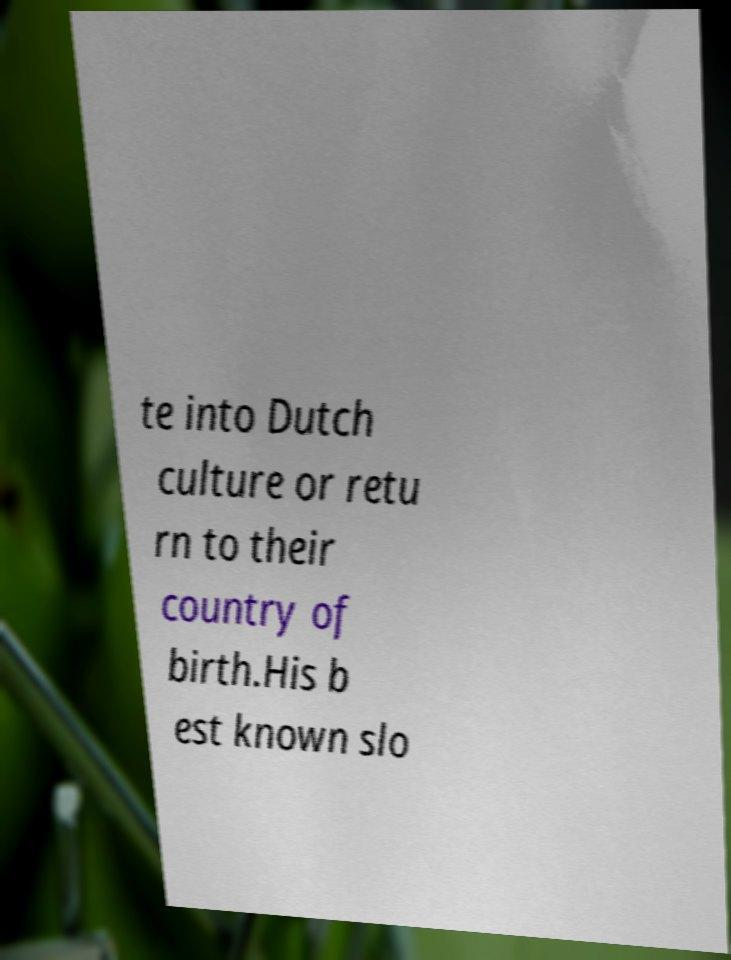What messages or text are displayed in this image? I need them in a readable, typed format. te into Dutch culture or retu rn to their country of birth.His b est known slo 